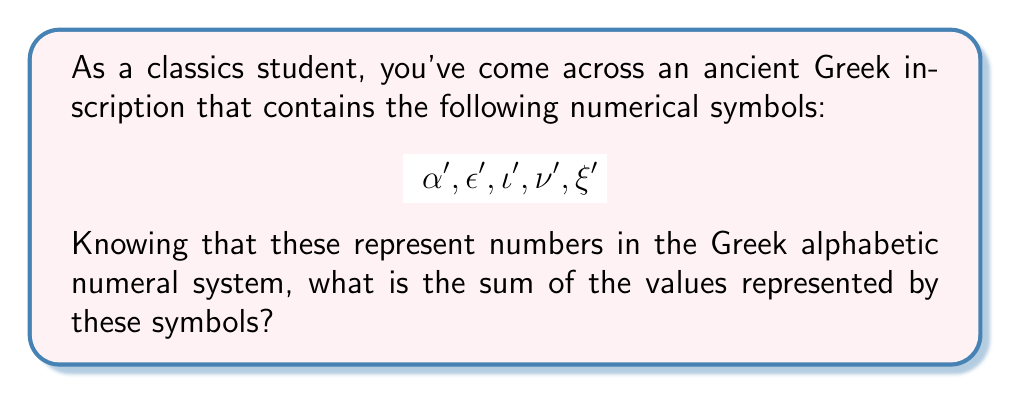Help me with this question. To solve this problem, we need to understand the Greek alphabetic numeral system:

1) In this system, letters of the Greek alphabet were used to represent numbers.
2) The system used 27 symbols: the 24 letters of the Greek alphabet plus 3 obsolete letters.
3) Each symbol is usually followed by a keraia (´) to distinguish it from regular text.

The values of the symbols in the question are:

- $\alpha'$ = 1
- $\epsilon'$ = 5
- $\iota'$ = 10
- $\nu'$ = 50
- $\xi'$ = 60

To find the sum, we simply add these values:

$$1 + 5 + 10 + 50 + 60 = 126$$

Therefore, the sum of the values represented by these symbols is 126.
Answer: 126 